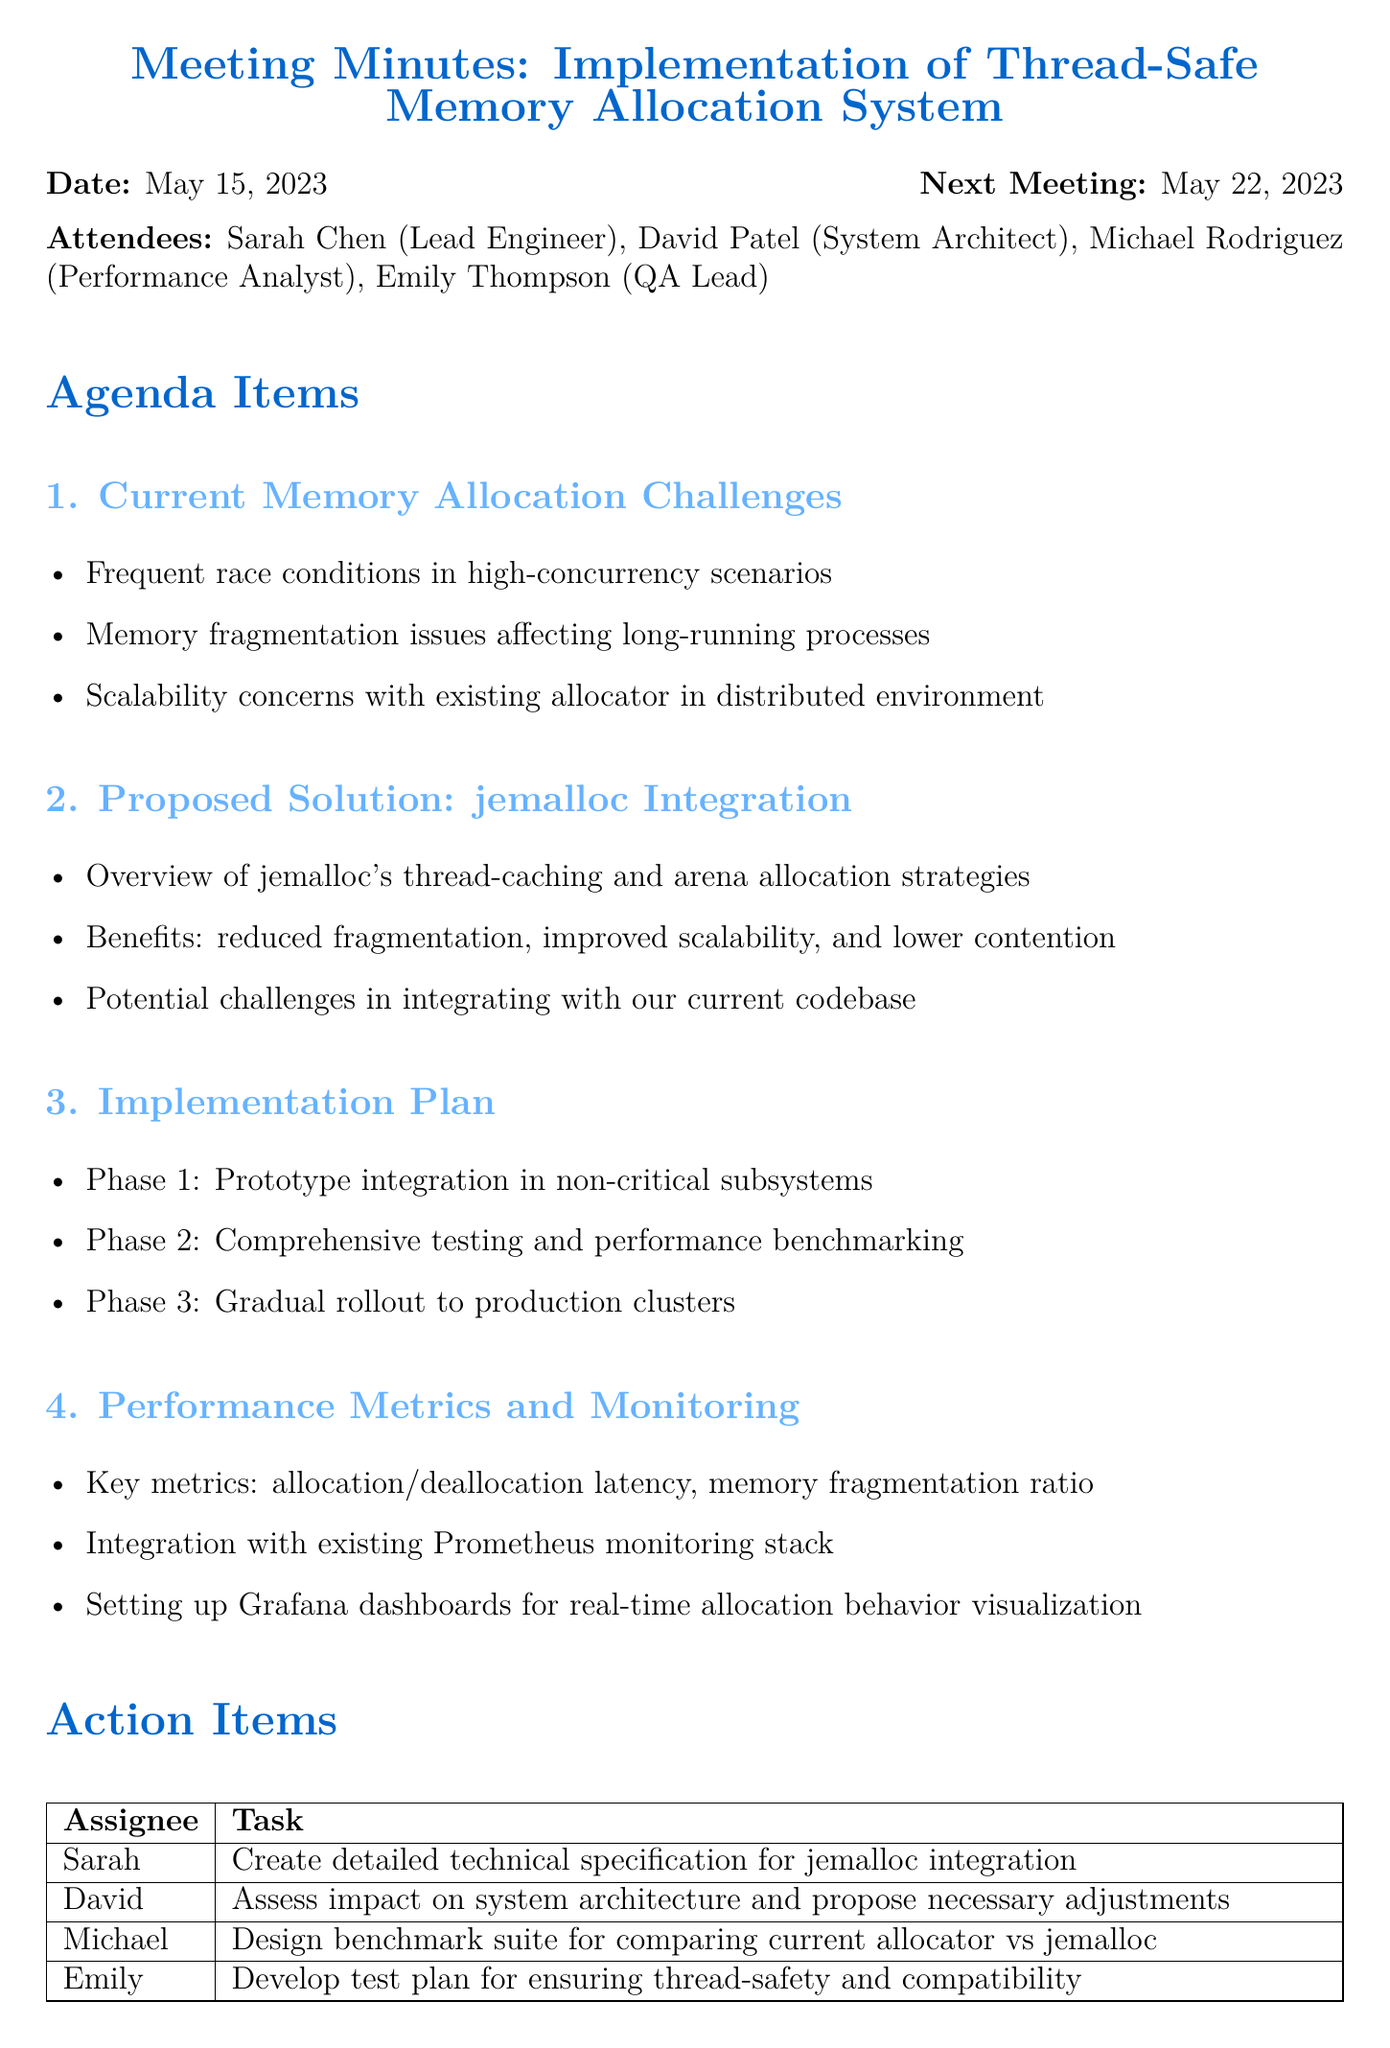What is the meeting title? The title is indicated at the beginning of the document, summarizing the main topic discussed.
Answer: Implementation of Thread-Safe Memory Allocation System for Large-Scale Distributed Application Who is the lead engineer? The lead engineer is listed among the attendees, indicating their role and identity.
Answer: Sarah Chen What are the three phases of the implementation plan? The phases are detailed in the implementation plan section, outlining the steps for integration.
Answer: Prototype integration, comprehensive testing, gradual rollout What is the next meeting date? The next meeting date is mentioned at the top alongside the current meeting date.
Answer: May 22, 2023 What key metrics will be monitored? The performance metrics section specifies key elements that will be tracked for monitoring.
Answer: Allocation/deallocation latency, memory fragmentation ratio What is the proposed solution for memory allocation challenges? The proposed solution is highlighted in the agenda items, indicating a specific strategy to address challenges.
Answer: Jemalloc Integration Who is responsible for developing a test plan? The action items specify who is assigned to each task, including developing the test plan.
Answer: Emily What challenges might arise during integration? The document discusses potential challenges that need consideration when implementing the solution.
Answer: Integrating with current codebase 